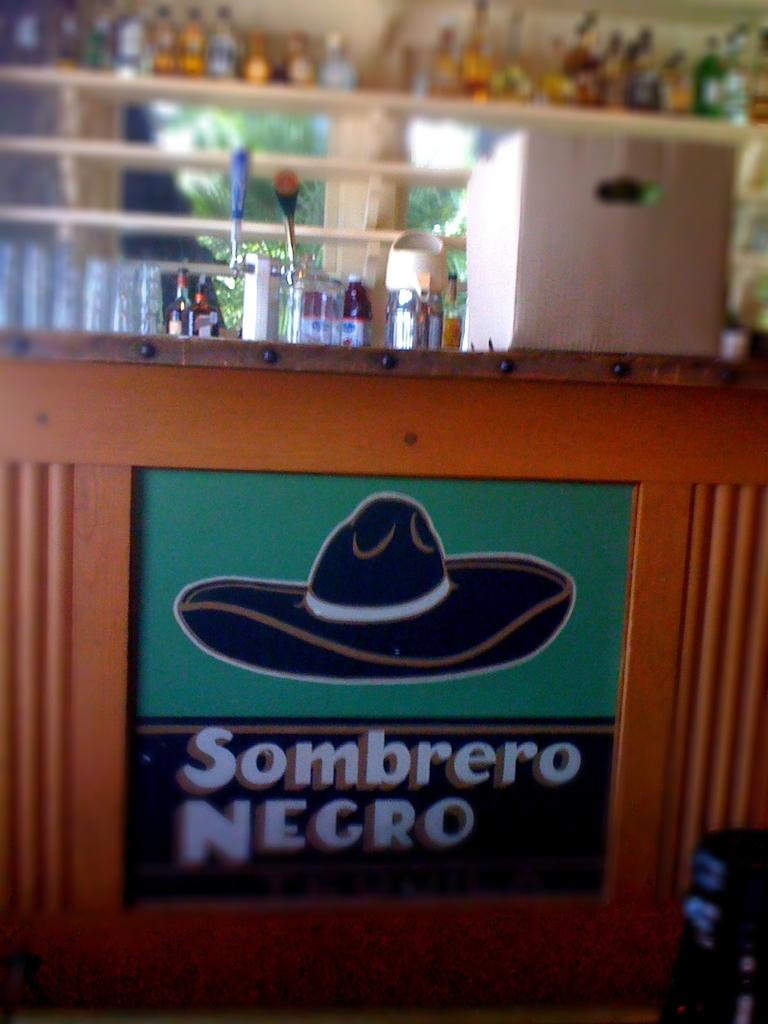<image>
Provide a brief description of the given image. a table with a sign that says sombrero negro with a drawn on black hat. 